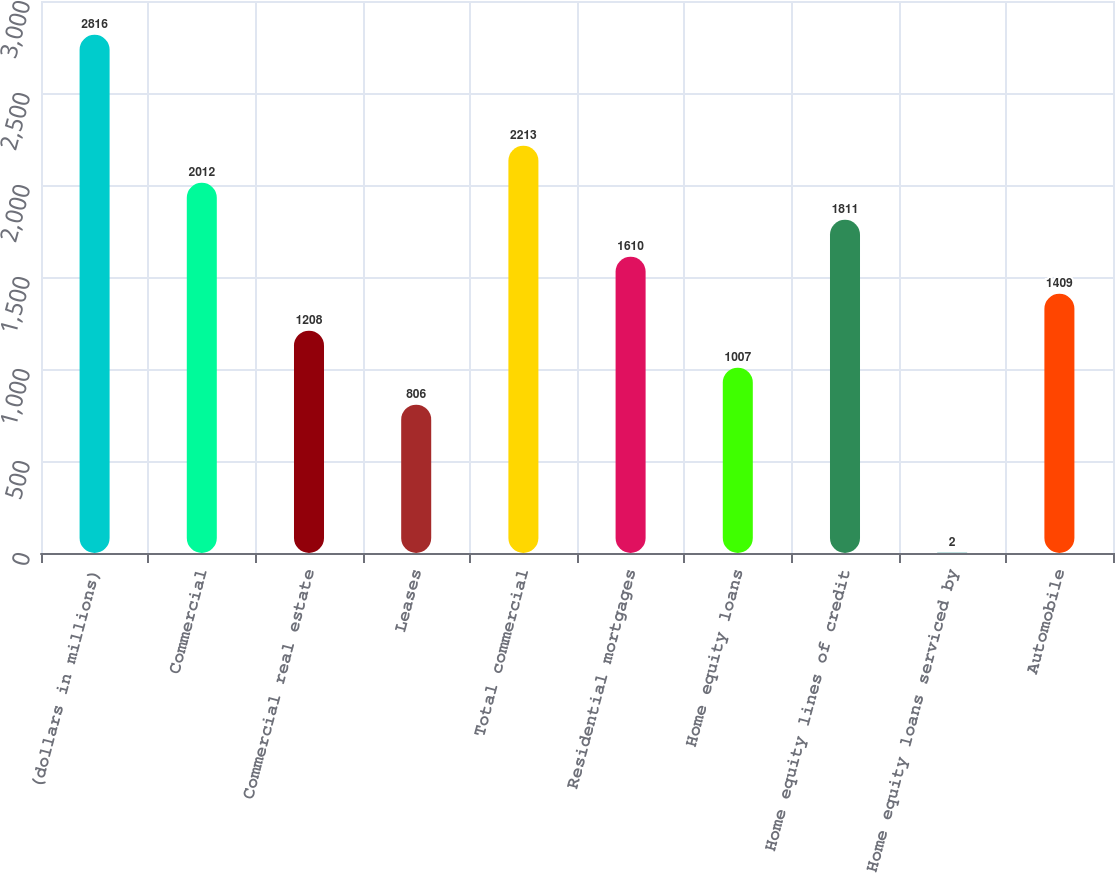Convert chart. <chart><loc_0><loc_0><loc_500><loc_500><bar_chart><fcel>(dollars in millions)<fcel>Commercial<fcel>Commercial real estate<fcel>Leases<fcel>Total commercial<fcel>Residential mortgages<fcel>Home equity loans<fcel>Home equity lines of credit<fcel>Home equity loans serviced by<fcel>Automobile<nl><fcel>2816<fcel>2012<fcel>1208<fcel>806<fcel>2213<fcel>1610<fcel>1007<fcel>1811<fcel>2<fcel>1409<nl></chart> 